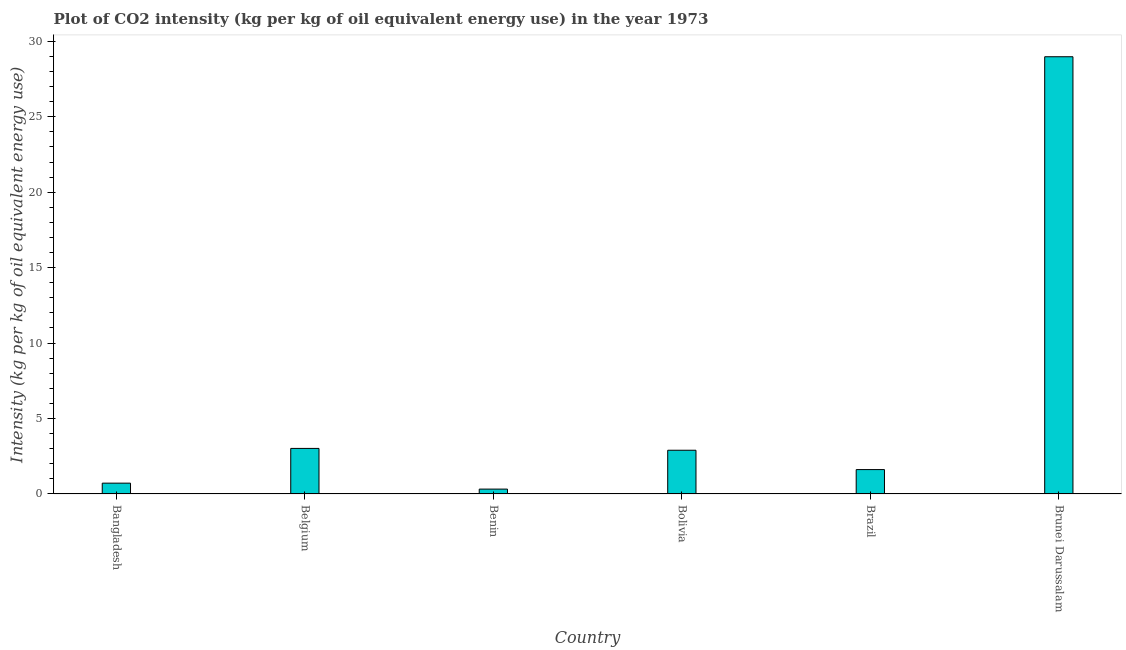What is the title of the graph?
Your answer should be very brief. Plot of CO2 intensity (kg per kg of oil equivalent energy use) in the year 1973. What is the label or title of the X-axis?
Your answer should be compact. Country. What is the label or title of the Y-axis?
Your answer should be very brief. Intensity (kg per kg of oil equivalent energy use). What is the co2 intensity in Brazil?
Give a very brief answer. 1.62. Across all countries, what is the maximum co2 intensity?
Make the answer very short. 28.98. Across all countries, what is the minimum co2 intensity?
Provide a succinct answer. 0.32. In which country was the co2 intensity maximum?
Your answer should be very brief. Brunei Darussalam. In which country was the co2 intensity minimum?
Make the answer very short. Benin. What is the sum of the co2 intensity?
Ensure brevity in your answer.  37.55. What is the difference between the co2 intensity in Bangladesh and Brazil?
Ensure brevity in your answer.  -0.9. What is the average co2 intensity per country?
Provide a succinct answer. 6.26. What is the median co2 intensity?
Keep it short and to the point. 2.26. In how many countries, is the co2 intensity greater than 16 kg?
Give a very brief answer. 1. What is the ratio of the co2 intensity in Bangladesh to that in Brunei Darussalam?
Your answer should be compact. 0.03. Is the difference between the co2 intensity in Bangladesh and Belgium greater than the difference between any two countries?
Your answer should be compact. No. What is the difference between the highest and the second highest co2 intensity?
Give a very brief answer. 25.96. What is the difference between the highest and the lowest co2 intensity?
Give a very brief answer. 28.66. In how many countries, is the co2 intensity greater than the average co2 intensity taken over all countries?
Your answer should be compact. 1. How many bars are there?
Your response must be concise. 6. How many countries are there in the graph?
Your answer should be very brief. 6. What is the difference between two consecutive major ticks on the Y-axis?
Offer a very short reply. 5. Are the values on the major ticks of Y-axis written in scientific E-notation?
Make the answer very short. No. What is the Intensity (kg per kg of oil equivalent energy use) of Bangladesh?
Your response must be concise. 0.72. What is the Intensity (kg per kg of oil equivalent energy use) of Belgium?
Give a very brief answer. 3.02. What is the Intensity (kg per kg of oil equivalent energy use) in Benin?
Provide a short and direct response. 0.32. What is the Intensity (kg per kg of oil equivalent energy use) of Bolivia?
Make the answer very short. 2.9. What is the Intensity (kg per kg of oil equivalent energy use) in Brazil?
Provide a succinct answer. 1.62. What is the Intensity (kg per kg of oil equivalent energy use) in Brunei Darussalam?
Give a very brief answer. 28.98. What is the difference between the Intensity (kg per kg of oil equivalent energy use) in Bangladesh and Belgium?
Keep it short and to the point. -2.3. What is the difference between the Intensity (kg per kg of oil equivalent energy use) in Bangladesh and Benin?
Keep it short and to the point. 0.39. What is the difference between the Intensity (kg per kg of oil equivalent energy use) in Bangladesh and Bolivia?
Provide a short and direct response. -2.18. What is the difference between the Intensity (kg per kg of oil equivalent energy use) in Bangladesh and Brazil?
Make the answer very short. -0.9. What is the difference between the Intensity (kg per kg of oil equivalent energy use) in Bangladesh and Brunei Darussalam?
Your answer should be very brief. -28.26. What is the difference between the Intensity (kg per kg of oil equivalent energy use) in Belgium and Benin?
Your answer should be compact. 2.7. What is the difference between the Intensity (kg per kg of oil equivalent energy use) in Belgium and Bolivia?
Provide a short and direct response. 0.12. What is the difference between the Intensity (kg per kg of oil equivalent energy use) in Belgium and Brazil?
Your answer should be very brief. 1.4. What is the difference between the Intensity (kg per kg of oil equivalent energy use) in Belgium and Brunei Darussalam?
Offer a terse response. -25.96. What is the difference between the Intensity (kg per kg of oil equivalent energy use) in Benin and Bolivia?
Your answer should be very brief. -2.58. What is the difference between the Intensity (kg per kg of oil equivalent energy use) in Benin and Brazil?
Offer a terse response. -1.29. What is the difference between the Intensity (kg per kg of oil equivalent energy use) in Benin and Brunei Darussalam?
Make the answer very short. -28.66. What is the difference between the Intensity (kg per kg of oil equivalent energy use) in Bolivia and Brazil?
Offer a very short reply. 1.28. What is the difference between the Intensity (kg per kg of oil equivalent energy use) in Bolivia and Brunei Darussalam?
Provide a succinct answer. -26.08. What is the difference between the Intensity (kg per kg of oil equivalent energy use) in Brazil and Brunei Darussalam?
Provide a short and direct response. -27.36. What is the ratio of the Intensity (kg per kg of oil equivalent energy use) in Bangladesh to that in Belgium?
Your answer should be compact. 0.24. What is the ratio of the Intensity (kg per kg of oil equivalent energy use) in Bangladesh to that in Benin?
Your answer should be compact. 2.22. What is the ratio of the Intensity (kg per kg of oil equivalent energy use) in Bangladesh to that in Bolivia?
Keep it short and to the point. 0.25. What is the ratio of the Intensity (kg per kg of oil equivalent energy use) in Bangladesh to that in Brazil?
Provide a succinct answer. 0.44. What is the ratio of the Intensity (kg per kg of oil equivalent energy use) in Bangladesh to that in Brunei Darussalam?
Provide a succinct answer. 0.03. What is the ratio of the Intensity (kg per kg of oil equivalent energy use) in Belgium to that in Benin?
Your response must be concise. 9.36. What is the ratio of the Intensity (kg per kg of oil equivalent energy use) in Belgium to that in Bolivia?
Provide a short and direct response. 1.04. What is the ratio of the Intensity (kg per kg of oil equivalent energy use) in Belgium to that in Brazil?
Offer a very short reply. 1.87. What is the ratio of the Intensity (kg per kg of oil equivalent energy use) in Belgium to that in Brunei Darussalam?
Ensure brevity in your answer.  0.1. What is the ratio of the Intensity (kg per kg of oil equivalent energy use) in Benin to that in Bolivia?
Provide a short and direct response. 0.11. What is the ratio of the Intensity (kg per kg of oil equivalent energy use) in Benin to that in Brunei Darussalam?
Ensure brevity in your answer.  0.01. What is the ratio of the Intensity (kg per kg of oil equivalent energy use) in Bolivia to that in Brazil?
Provide a succinct answer. 1.79. What is the ratio of the Intensity (kg per kg of oil equivalent energy use) in Brazil to that in Brunei Darussalam?
Keep it short and to the point. 0.06. 